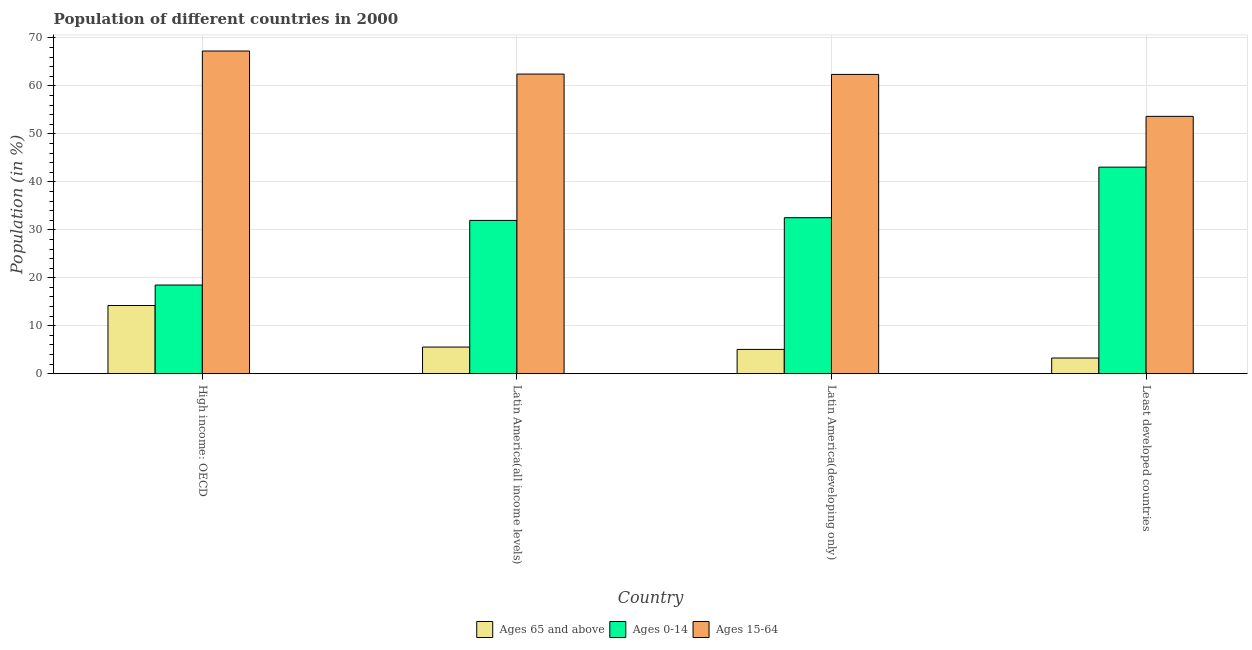How many different coloured bars are there?
Offer a very short reply. 3. How many groups of bars are there?
Make the answer very short. 4. Are the number of bars per tick equal to the number of legend labels?
Your answer should be compact. Yes. How many bars are there on the 1st tick from the left?
Your answer should be very brief. 3. How many bars are there on the 1st tick from the right?
Ensure brevity in your answer.  3. What is the label of the 3rd group of bars from the left?
Offer a very short reply. Latin America(developing only). What is the percentage of population within the age-group 15-64 in Latin America(developing only)?
Offer a terse response. 62.4. Across all countries, what is the maximum percentage of population within the age-group of 65 and above?
Provide a short and direct response. 14.23. Across all countries, what is the minimum percentage of population within the age-group 15-64?
Your response must be concise. 53.66. In which country was the percentage of population within the age-group 0-14 maximum?
Offer a very short reply. Least developed countries. In which country was the percentage of population within the age-group 15-64 minimum?
Provide a short and direct response. Least developed countries. What is the total percentage of population within the age-group 15-64 in the graph?
Keep it short and to the point. 245.8. What is the difference between the percentage of population within the age-group of 65 and above in Latin America(developing only) and that in Least developed countries?
Your answer should be very brief. 1.8. What is the difference between the percentage of population within the age-group 0-14 in Latin America(all income levels) and the percentage of population within the age-group of 65 and above in Latin America(developing only)?
Offer a terse response. 26.89. What is the average percentage of population within the age-group of 65 and above per country?
Provide a succinct answer. 7.03. What is the difference between the percentage of population within the age-group 0-14 and percentage of population within the age-group 15-64 in Latin America(developing only)?
Your response must be concise. -29.87. In how many countries, is the percentage of population within the age-group 15-64 greater than 56 %?
Provide a short and direct response. 3. What is the ratio of the percentage of population within the age-group 15-64 in High income: OECD to that in Latin America(developing only)?
Give a very brief answer. 1.08. Is the difference between the percentage of population within the age-group 15-64 in High income: OECD and Least developed countries greater than the difference between the percentage of population within the age-group 0-14 in High income: OECD and Least developed countries?
Your answer should be compact. Yes. What is the difference between the highest and the second highest percentage of population within the age-group 15-64?
Keep it short and to the point. 4.81. What is the difference between the highest and the lowest percentage of population within the age-group of 65 and above?
Make the answer very short. 10.95. In how many countries, is the percentage of population within the age-group 0-14 greater than the average percentage of population within the age-group 0-14 taken over all countries?
Make the answer very short. 3. Is the sum of the percentage of population within the age-group of 65 and above in High income: OECD and Latin America(developing only) greater than the maximum percentage of population within the age-group 0-14 across all countries?
Offer a very short reply. No. What does the 1st bar from the left in Latin America(all income levels) represents?
Keep it short and to the point. Ages 65 and above. What does the 3rd bar from the right in High income: OECD represents?
Provide a short and direct response. Ages 65 and above. Is it the case that in every country, the sum of the percentage of population within the age-group of 65 and above and percentage of population within the age-group 0-14 is greater than the percentage of population within the age-group 15-64?
Your answer should be compact. No. Does the graph contain grids?
Make the answer very short. Yes. How are the legend labels stacked?
Your answer should be compact. Horizontal. What is the title of the graph?
Ensure brevity in your answer.  Population of different countries in 2000. Does "Gaseous fuel" appear as one of the legend labels in the graph?
Give a very brief answer. No. What is the label or title of the X-axis?
Provide a short and direct response. Country. What is the Population (in %) of Ages 65 and above in High income: OECD?
Your answer should be compact. 14.23. What is the Population (in %) in Ages 0-14 in High income: OECD?
Keep it short and to the point. 18.5. What is the Population (in %) in Ages 15-64 in High income: OECD?
Keep it short and to the point. 67.28. What is the Population (in %) of Ages 65 and above in Latin America(all income levels)?
Give a very brief answer. 5.56. What is the Population (in %) of Ages 0-14 in Latin America(all income levels)?
Make the answer very short. 31.97. What is the Population (in %) in Ages 15-64 in Latin America(all income levels)?
Offer a very short reply. 62.47. What is the Population (in %) of Ages 65 and above in Latin America(developing only)?
Your answer should be compact. 5.07. What is the Population (in %) of Ages 0-14 in Latin America(developing only)?
Provide a short and direct response. 32.53. What is the Population (in %) of Ages 15-64 in Latin America(developing only)?
Ensure brevity in your answer.  62.4. What is the Population (in %) in Ages 65 and above in Least developed countries?
Provide a short and direct response. 3.27. What is the Population (in %) in Ages 0-14 in Least developed countries?
Your answer should be compact. 43.07. What is the Population (in %) of Ages 15-64 in Least developed countries?
Make the answer very short. 53.66. Across all countries, what is the maximum Population (in %) in Ages 65 and above?
Offer a terse response. 14.23. Across all countries, what is the maximum Population (in %) of Ages 0-14?
Provide a succinct answer. 43.07. Across all countries, what is the maximum Population (in %) of Ages 15-64?
Make the answer very short. 67.28. Across all countries, what is the minimum Population (in %) in Ages 65 and above?
Ensure brevity in your answer.  3.27. Across all countries, what is the minimum Population (in %) of Ages 0-14?
Give a very brief answer. 18.5. Across all countries, what is the minimum Population (in %) in Ages 15-64?
Your answer should be compact. 53.66. What is the total Population (in %) of Ages 65 and above in the graph?
Your answer should be compact. 28.14. What is the total Population (in %) of Ages 0-14 in the graph?
Offer a terse response. 126.06. What is the total Population (in %) of Ages 15-64 in the graph?
Provide a short and direct response. 245.8. What is the difference between the Population (in %) in Ages 65 and above in High income: OECD and that in Latin America(all income levels)?
Offer a terse response. 8.66. What is the difference between the Population (in %) of Ages 0-14 in High income: OECD and that in Latin America(all income levels)?
Your response must be concise. -13.47. What is the difference between the Population (in %) in Ages 15-64 in High income: OECD and that in Latin America(all income levels)?
Offer a terse response. 4.81. What is the difference between the Population (in %) in Ages 65 and above in High income: OECD and that in Latin America(developing only)?
Offer a terse response. 9.15. What is the difference between the Population (in %) of Ages 0-14 in High income: OECD and that in Latin America(developing only)?
Make the answer very short. -14.03. What is the difference between the Population (in %) of Ages 15-64 in High income: OECD and that in Latin America(developing only)?
Offer a terse response. 4.88. What is the difference between the Population (in %) in Ages 65 and above in High income: OECD and that in Least developed countries?
Your response must be concise. 10.95. What is the difference between the Population (in %) in Ages 0-14 in High income: OECD and that in Least developed countries?
Make the answer very short. -24.57. What is the difference between the Population (in %) of Ages 15-64 in High income: OECD and that in Least developed countries?
Offer a terse response. 13.62. What is the difference between the Population (in %) in Ages 65 and above in Latin America(all income levels) and that in Latin America(developing only)?
Give a very brief answer. 0.49. What is the difference between the Population (in %) of Ages 0-14 in Latin America(all income levels) and that in Latin America(developing only)?
Offer a terse response. -0.56. What is the difference between the Population (in %) in Ages 15-64 in Latin America(all income levels) and that in Latin America(developing only)?
Make the answer very short. 0.07. What is the difference between the Population (in %) in Ages 65 and above in Latin America(all income levels) and that in Least developed countries?
Offer a terse response. 2.29. What is the difference between the Population (in %) in Ages 0-14 in Latin America(all income levels) and that in Least developed countries?
Offer a very short reply. -11.1. What is the difference between the Population (in %) in Ages 15-64 in Latin America(all income levels) and that in Least developed countries?
Provide a succinct answer. 8.81. What is the difference between the Population (in %) in Ages 65 and above in Latin America(developing only) and that in Least developed countries?
Keep it short and to the point. 1.8. What is the difference between the Population (in %) in Ages 0-14 in Latin America(developing only) and that in Least developed countries?
Your response must be concise. -10.54. What is the difference between the Population (in %) in Ages 15-64 in Latin America(developing only) and that in Least developed countries?
Provide a succinct answer. 8.74. What is the difference between the Population (in %) of Ages 65 and above in High income: OECD and the Population (in %) of Ages 0-14 in Latin America(all income levels)?
Your answer should be compact. -17.74. What is the difference between the Population (in %) of Ages 65 and above in High income: OECD and the Population (in %) of Ages 15-64 in Latin America(all income levels)?
Make the answer very short. -48.24. What is the difference between the Population (in %) of Ages 0-14 in High income: OECD and the Population (in %) of Ages 15-64 in Latin America(all income levels)?
Your answer should be very brief. -43.97. What is the difference between the Population (in %) of Ages 65 and above in High income: OECD and the Population (in %) of Ages 0-14 in Latin America(developing only)?
Provide a succinct answer. -18.3. What is the difference between the Population (in %) in Ages 65 and above in High income: OECD and the Population (in %) in Ages 15-64 in Latin America(developing only)?
Your answer should be compact. -48.17. What is the difference between the Population (in %) of Ages 0-14 in High income: OECD and the Population (in %) of Ages 15-64 in Latin America(developing only)?
Offer a very short reply. -43.9. What is the difference between the Population (in %) of Ages 65 and above in High income: OECD and the Population (in %) of Ages 0-14 in Least developed countries?
Offer a terse response. -28.84. What is the difference between the Population (in %) of Ages 65 and above in High income: OECD and the Population (in %) of Ages 15-64 in Least developed countries?
Keep it short and to the point. -39.43. What is the difference between the Population (in %) in Ages 0-14 in High income: OECD and the Population (in %) in Ages 15-64 in Least developed countries?
Provide a short and direct response. -35.16. What is the difference between the Population (in %) of Ages 65 and above in Latin America(all income levels) and the Population (in %) of Ages 0-14 in Latin America(developing only)?
Your answer should be very brief. -26.97. What is the difference between the Population (in %) in Ages 65 and above in Latin America(all income levels) and the Population (in %) in Ages 15-64 in Latin America(developing only)?
Give a very brief answer. -56.84. What is the difference between the Population (in %) in Ages 0-14 in Latin America(all income levels) and the Population (in %) in Ages 15-64 in Latin America(developing only)?
Keep it short and to the point. -30.43. What is the difference between the Population (in %) in Ages 65 and above in Latin America(all income levels) and the Population (in %) in Ages 0-14 in Least developed countries?
Your answer should be very brief. -37.51. What is the difference between the Population (in %) of Ages 65 and above in Latin America(all income levels) and the Population (in %) of Ages 15-64 in Least developed countries?
Give a very brief answer. -48.09. What is the difference between the Population (in %) in Ages 0-14 in Latin America(all income levels) and the Population (in %) in Ages 15-64 in Least developed countries?
Give a very brief answer. -21.69. What is the difference between the Population (in %) in Ages 65 and above in Latin America(developing only) and the Population (in %) in Ages 0-14 in Least developed countries?
Offer a very short reply. -38. What is the difference between the Population (in %) in Ages 65 and above in Latin America(developing only) and the Population (in %) in Ages 15-64 in Least developed countries?
Your response must be concise. -48.58. What is the difference between the Population (in %) in Ages 0-14 in Latin America(developing only) and the Population (in %) in Ages 15-64 in Least developed countries?
Your answer should be very brief. -21.13. What is the average Population (in %) of Ages 65 and above per country?
Your answer should be very brief. 7.03. What is the average Population (in %) in Ages 0-14 per country?
Ensure brevity in your answer.  31.52. What is the average Population (in %) of Ages 15-64 per country?
Your response must be concise. 61.45. What is the difference between the Population (in %) of Ages 65 and above and Population (in %) of Ages 0-14 in High income: OECD?
Offer a terse response. -4.27. What is the difference between the Population (in %) of Ages 65 and above and Population (in %) of Ages 15-64 in High income: OECD?
Provide a short and direct response. -53.05. What is the difference between the Population (in %) in Ages 0-14 and Population (in %) in Ages 15-64 in High income: OECD?
Give a very brief answer. -48.78. What is the difference between the Population (in %) in Ages 65 and above and Population (in %) in Ages 0-14 in Latin America(all income levels)?
Your answer should be very brief. -26.4. What is the difference between the Population (in %) of Ages 65 and above and Population (in %) of Ages 15-64 in Latin America(all income levels)?
Your answer should be compact. -56.91. What is the difference between the Population (in %) of Ages 0-14 and Population (in %) of Ages 15-64 in Latin America(all income levels)?
Your response must be concise. -30.5. What is the difference between the Population (in %) of Ages 65 and above and Population (in %) of Ages 0-14 in Latin America(developing only)?
Provide a short and direct response. -27.46. What is the difference between the Population (in %) in Ages 65 and above and Population (in %) in Ages 15-64 in Latin America(developing only)?
Keep it short and to the point. -57.33. What is the difference between the Population (in %) of Ages 0-14 and Population (in %) of Ages 15-64 in Latin America(developing only)?
Provide a short and direct response. -29.87. What is the difference between the Population (in %) of Ages 65 and above and Population (in %) of Ages 0-14 in Least developed countries?
Provide a succinct answer. -39.79. What is the difference between the Population (in %) of Ages 65 and above and Population (in %) of Ages 15-64 in Least developed countries?
Give a very brief answer. -50.38. What is the difference between the Population (in %) in Ages 0-14 and Population (in %) in Ages 15-64 in Least developed countries?
Keep it short and to the point. -10.59. What is the ratio of the Population (in %) of Ages 65 and above in High income: OECD to that in Latin America(all income levels)?
Keep it short and to the point. 2.56. What is the ratio of the Population (in %) in Ages 0-14 in High income: OECD to that in Latin America(all income levels)?
Make the answer very short. 0.58. What is the ratio of the Population (in %) of Ages 15-64 in High income: OECD to that in Latin America(all income levels)?
Provide a succinct answer. 1.08. What is the ratio of the Population (in %) of Ages 65 and above in High income: OECD to that in Latin America(developing only)?
Provide a succinct answer. 2.8. What is the ratio of the Population (in %) in Ages 0-14 in High income: OECD to that in Latin America(developing only)?
Give a very brief answer. 0.57. What is the ratio of the Population (in %) of Ages 15-64 in High income: OECD to that in Latin America(developing only)?
Offer a very short reply. 1.08. What is the ratio of the Population (in %) in Ages 65 and above in High income: OECD to that in Least developed countries?
Keep it short and to the point. 4.34. What is the ratio of the Population (in %) of Ages 0-14 in High income: OECD to that in Least developed countries?
Provide a succinct answer. 0.43. What is the ratio of the Population (in %) in Ages 15-64 in High income: OECD to that in Least developed countries?
Provide a succinct answer. 1.25. What is the ratio of the Population (in %) of Ages 65 and above in Latin America(all income levels) to that in Latin America(developing only)?
Your answer should be compact. 1.1. What is the ratio of the Population (in %) in Ages 0-14 in Latin America(all income levels) to that in Latin America(developing only)?
Your answer should be compact. 0.98. What is the ratio of the Population (in %) of Ages 65 and above in Latin America(all income levels) to that in Least developed countries?
Provide a short and direct response. 1.7. What is the ratio of the Population (in %) of Ages 0-14 in Latin America(all income levels) to that in Least developed countries?
Make the answer very short. 0.74. What is the ratio of the Population (in %) in Ages 15-64 in Latin America(all income levels) to that in Least developed countries?
Offer a terse response. 1.16. What is the ratio of the Population (in %) of Ages 65 and above in Latin America(developing only) to that in Least developed countries?
Your answer should be compact. 1.55. What is the ratio of the Population (in %) in Ages 0-14 in Latin America(developing only) to that in Least developed countries?
Offer a terse response. 0.76. What is the ratio of the Population (in %) in Ages 15-64 in Latin America(developing only) to that in Least developed countries?
Your answer should be very brief. 1.16. What is the difference between the highest and the second highest Population (in %) of Ages 65 and above?
Provide a short and direct response. 8.66. What is the difference between the highest and the second highest Population (in %) of Ages 0-14?
Your answer should be very brief. 10.54. What is the difference between the highest and the second highest Population (in %) of Ages 15-64?
Your response must be concise. 4.81. What is the difference between the highest and the lowest Population (in %) of Ages 65 and above?
Your response must be concise. 10.95. What is the difference between the highest and the lowest Population (in %) of Ages 0-14?
Provide a short and direct response. 24.57. What is the difference between the highest and the lowest Population (in %) of Ages 15-64?
Keep it short and to the point. 13.62. 